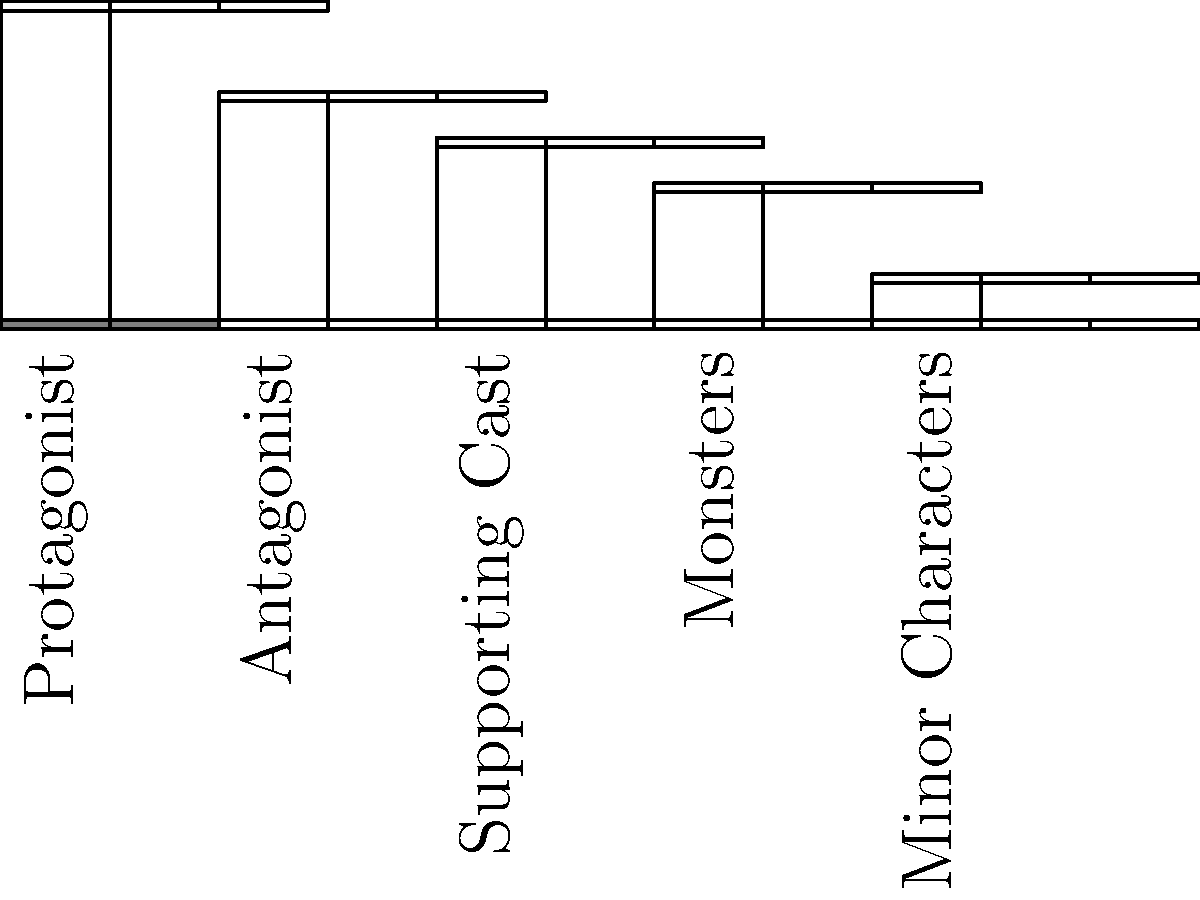In this Resident Evil-inspired horror film, which character archetype has the second-highest screen time percentage, and what is the difference in screen time between this archetype and the protagonist? To answer this question, we need to analyze the bar graph showing the screen time percentages for different character archetypes:

1. Identify the character archetypes and their screen time percentages:
   - Protagonist: 35%
   - Antagonist: 25%
   - Supporting Cast: 20%
   - Monsters: 15%
   - Minor Characters: 5%

2. Determine the archetype with the second-highest screen time:
   The Antagonist has 25%, which is the second-highest after the Protagonist's 35%.

3. Calculate the difference in screen time between the Antagonist and the Protagonist:
   Difference = Protagonist's screen time - Antagonist's screen time
               = 35% - 25%
               = 10%

Therefore, the Antagonist has the second-highest screen time, and the difference between the Antagonist's and the Protagonist's screen time is 10%.
Answer: Antagonist; 10% 